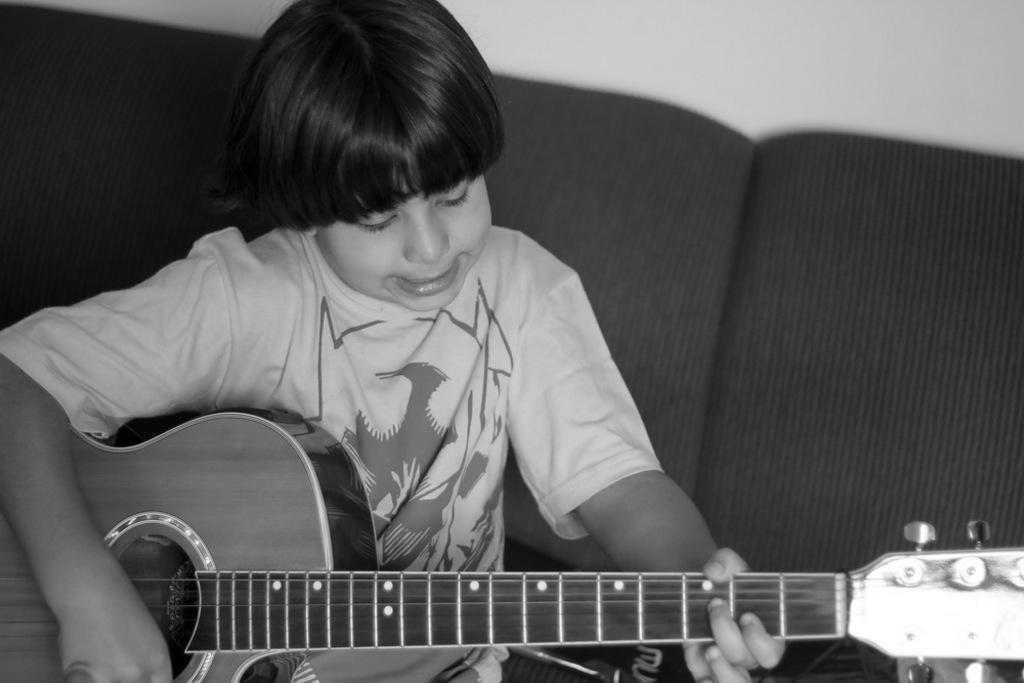Can you describe this image briefly? This is a picture of a boy siting on the couch, the boy is playing the guitar and the background of the boy is a white wall. 